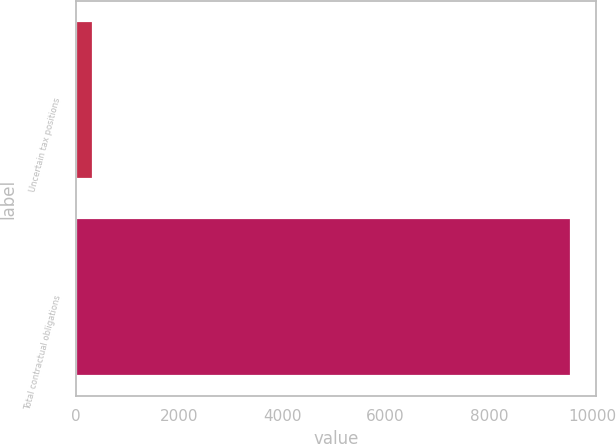Convert chart to OTSL. <chart><loc_0><loc_0><loc_500><loc_500><bar_chart><fcel>Uncertain tax positions<fcel>Total contractual obligations<nl><fcel>332.9<fcel>9594.3<nl></chart> 